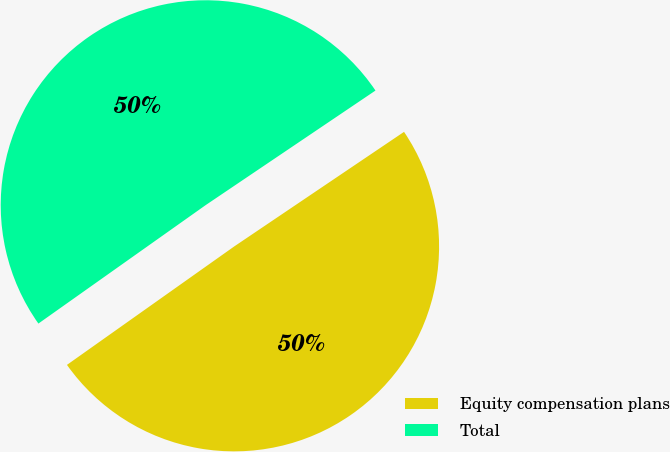Convert chart. <chart><loc_0><loc_0><loc_500><loc_500><pie_chart><fcel>Equity compensation plans<fcel>Total<nl><fcel>49.64%<fcel>50.36%<nl></chart> 